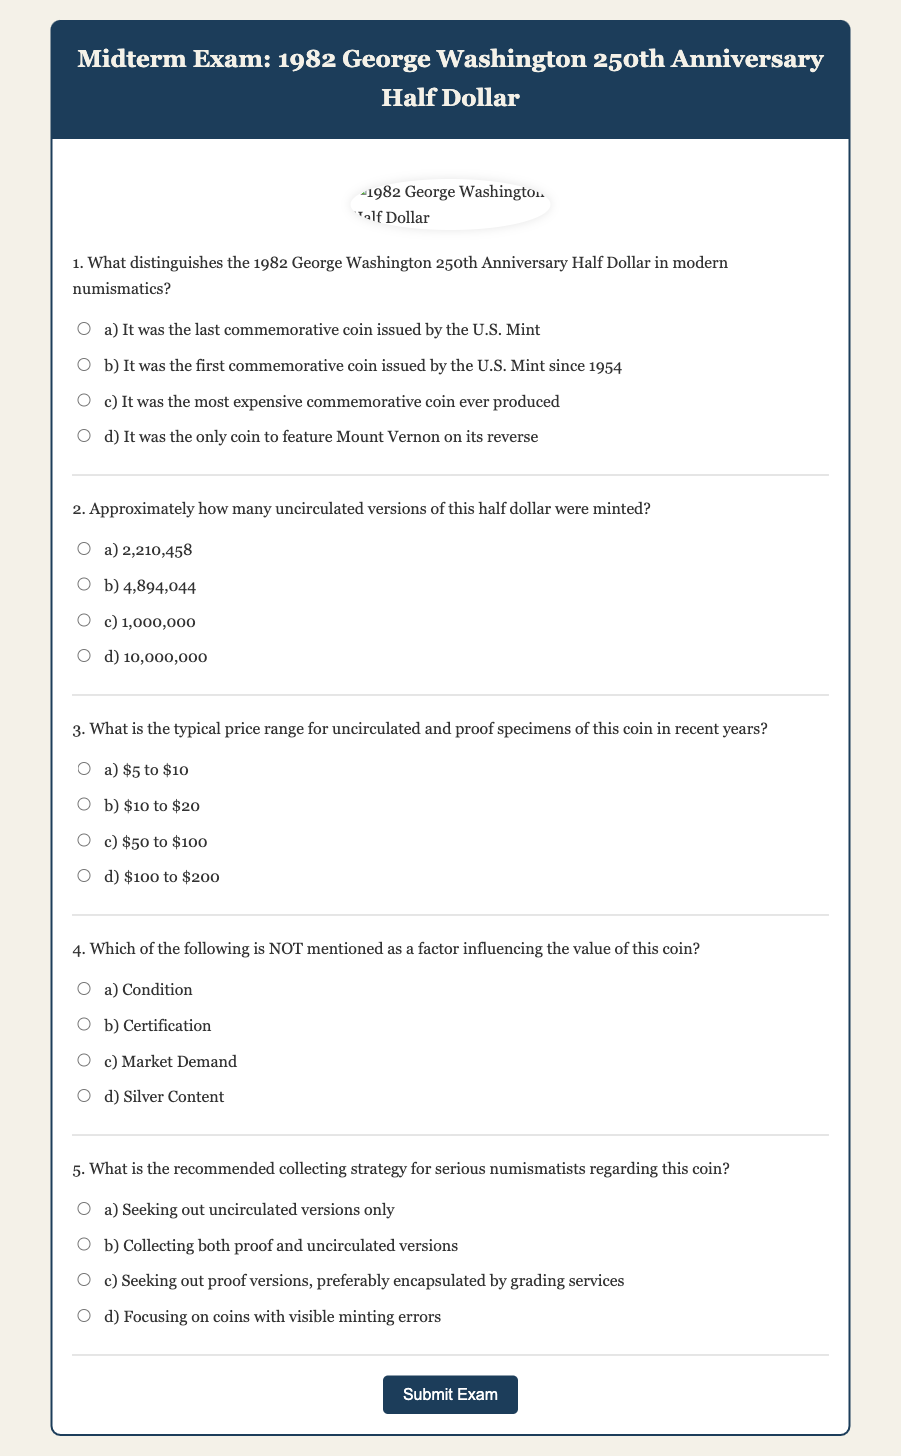What distinguishes the 1982 George Washington 250th Anniversary Half Dollar in modern numismatics? The answer can be found in question 1 of the document, which lists the options. The correct option among them will specifically state what sets this coin apart.
Answer: It was the first commemorative coin issued by the U.S. Mint since 1954 How many uncirculated versions of this half dollar were minted? The answer is found in question 2 of the document. The options provided will give the accurate mintage figure for uncirculated versions.
Answer: 2,210,458 What is the typical price range for uncirculated and proof specimens of this coin in recent years? The answer can be found in question 3, which presents multiple choices for the price range of these coins.
Answer: $10 to $20 Which factor is NOT mentioned as influencing the value of this coin? Based on question 4, options are provided that either are or are not cited as influencing factors. Selecting the correct option will reveal which factor is excluded.
Answer: Silver Content What is the recommended collecting strategy for serious numismatists regarding this coin? Question 5 contains the recommended strategies. The answer will correspond to one of the options given.
Answer: Collecting both proof and uncirculated versions 